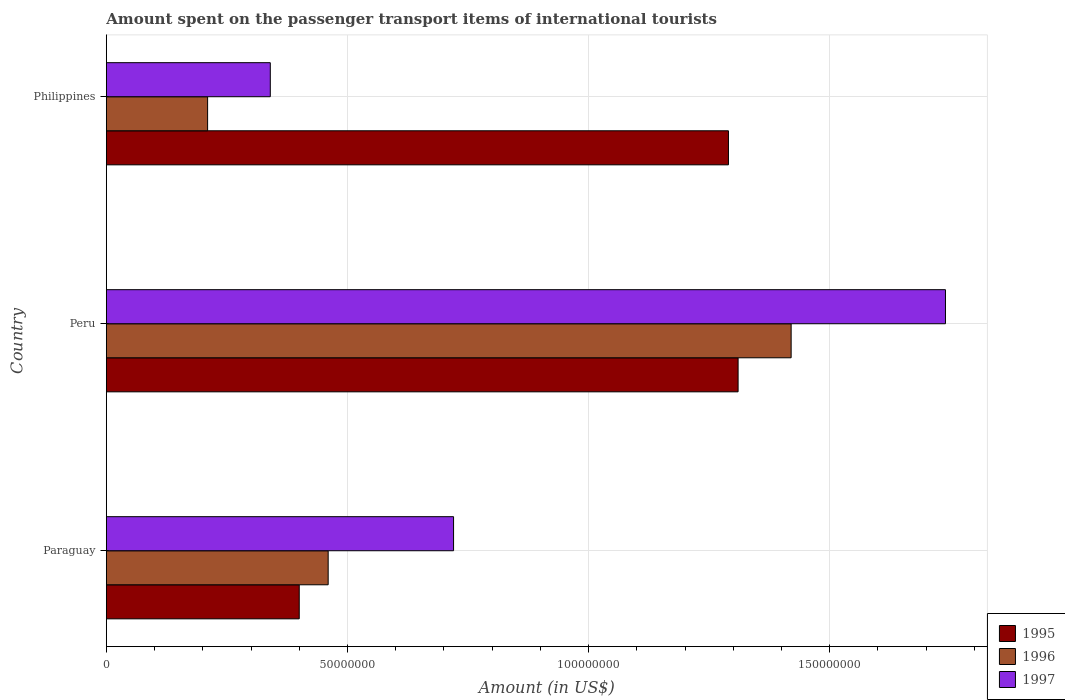How many different coloured bars are there?
Provide a short and direct response. 3. How many groups of bars are there?
Ensure brevity in your answer.  3. How many bars are there on the 3rd tick from the bottom?
Keep it short and to the point. 3. What is the label of the 3rd group of bars from the top?
Offer a terse response. Paraguay. In how many cases, is the number of bars for a given country not equal to the number of legend labels?
Keep it short and to the point. 0. What is the amount spent on the passenger transport items of international tourists in 1997 in Paraguay?
Keep it short and to the point. 7.20e+07. Across all countries, what is the maximum amount spent on the passenger transport items of international tourists in 1995?
Make the answer very short. 1.31e+08. Across all countries, what is the minimum amount spent on the passenger transport items of international tourists in 1997?
Keep it short and to the point. 3.40e+07. In which country was the amount spent on the passenger transport items of international tourists in 1996 minimum?
Your answer should be very brief. Philippines. What is the total amount spent on the passenger transport items of international tourists in 1996 in the graph?
Ensure brevity in your answer.  2.09e+08. What is the difference between the amount spent on the passenger transport items of international tourists in 1995 in Paraguay and that in Philippines?
Your answer should be very brief. -8.90e+07. What is the difference between the amount spent on the passenger transport items of international tourists in 1995 in Peru and the amount spent on the passenger transport items of international tourists in 1996 in Philippines?
Keep it short and to the point. 1.10e+08. What is the average amount spent on the passenger transport items of international tourists in 1997 per country?
Your answer should be compact. 9.33e+07. What is the difference between the amount spent on the passenger transport items of international tourists in 1995 and amount spent on the passenger transport items of international tourists in 1996 in Paraguay?
Your response must be concise. -6.00e+06. What is the ratio of the amount spent on the passenger transport items of international tourists in 1996 in Paraguay to that in Peru?
Provide a short and direct response. 0.32. Is the amount spent on the passenger transport items of international tourists in 1995 in Paraguay less than that in Peru?
Offer a very short reply. Yes. What is the difference between the highest and the second highest amount spent on the passenger transport items of international tourists in 1997?
Offer a very short reply. 1.02e+08. What is the difference between the highest and the lowest amount spent on the passenger transport items of international tourists in 1995?
Your response must be concise. 9.10e+07. In how many countries, is the amount spent on the passenger transport items of international tourists in 1996 greater than the average amount spent on the passenger transport items of international tourists in 1996 taken over all countries?
Keep it short and to the point. 1. Are all the bars in the graph horizontal?
Provide a short and direct response. Yes. How many countries are there in the graph?
Provide a succinct answer. 3. Does the graph contain grids?
Ensure brevity in your answer.  Yes. How many legend labels are there?
Provide a short and direct response. 3. How are the legend labels stacked?
Provide a succinct answer. Vertical. What is the title of the graph?
Keep it short and to the point. Amount spent on the passenger transport items of international tourists. What is the label or title of the Y-axis?
Your response must be concise. Country. What is the Amount (in US$) of 1995 in Paraguay?
Give a very brief answer. 4.00e+07. What is the Amount (in US$) of 1996 in Paraguay?
Give a very brief answer. 4.60e+07. What is the Amount (in US$) in 1997 in Paraguay?
Offer a terse response. 7.20e+07. What is the Amount (in US$) in 1995 in Peru?
Your answer should be compact. 1.31e+08. What is the Amount (in US$) of 1996 in Peru?
Your answer should be very brief. 1.42e+08. What is the Amount (in US$) of 1997 in Peru?
Your answer should be very brief. 1.74e+08. What is the Amount (in US$) in 1995 in Philippines?
Offer a very short reply. 1.29e+08. What is the Amount (in US$) in 1996 in Philippines?
Your answer should be compact. 2.10e+07. What is the Amount (in US$) of 1997 in Philippines?
Your answer should be compact. 3.40e+07. Across all countries, what is the maximum Amount (in US$) in 1995?
Offer a terse response. 1.31e+08. Across all countries, what is the maximum Amount (in US$) of 1996?
Ensure brevity in your answer.  1.42e+08. Across all countries, what is the maximum Amount (in US$) in 1997?
Keep it short and to the point. 1.74e+08. Across all countries, what is the minimum Amount (in US$) of 1995?
Your response must be concise. 4.00e+07. Across all countries, what is the minimum Amount (in US$) of 1996?
Your response must be concise. 2.10e+07. Across all countries, what is the minimum Amount (in US$) of 1997?
Your response must be concise. 3.40e+07. What is the total Amount (in US$) in 1995 in the graph?
Your answer should be compact. 3.00e+08. What is the total Amount (in US$) in 1996 in the graph?
Provide a succinct answer. 2.09e+08. What is the total Amount (in US$) of 1997 in the graph?
Ensure brevity in your answer.  2.80e+08. What is the difference between the Amount (in US$) in 1995 in Paraguay and that in Peru?
Offer a terse response. -9.10e+07. What is the difference between the Amount (in US$) of 1996 in Paraguay and that in Peru?
Ensure brevity in your answer.  -9.60e+07. What is the difference between the Amount (in US$) in 1997 in Paraguay and that in Peru?
Offer a terse response. -1.02e+08. What is the difference between the Amount (in US$) of 1995 in Paraguay and that in Philippines?
Your answer should be compact. -8.90e+07. What is the difference between the Amount (in US$) in 1996 in Paraguay and that in Philippines?
Provide a succinct answer. 2.50e+07. What is the difference between the Amount (in US$) of 1997 in Paraguay and that in Philippines?
Your answer should be compact. 3.80e+07. What is the difference between the Amount (in US$) in 1996 in Peru and that in Philippines?
Give a very brief answer. 1.21e+08. What is the difference between the Amount (in US$) in 1997 in Peru and that in Philippines?
Your response must be concise. 1.40e+08. What is the difference between the Amount (in US$) of 1995 in Paraguay and the Amount (in US$) of 1996 in Peru?
Your response must be concise. -1.02e+08. What is the difference between the Amount (in US$) in 1995 in Paraguay and the Amount (in US$) in 1997 in Peru?
Your answer should be compact. -1.34e+08. What is the difference between the Amount (in US$) of 1996 in Paraguay and the Amount (in US$) of 1997 in Peru?
Keep it short and to the point. -1.28e+08. What is the difference between the Amount (in US$) of 1995 in Paraguay and the Amount (in US$) of 1996 in Philippines?
Your answer should be very brief. 1.90e+07. What is the difference between the Amount (in US$) in 1995 in Paraguay and the Amount (in US$) in 1997 in Philippines?
Provide a succinct answer. 6.00e+06. What is the difference between the Amount (in US$) in 1996 in Paraguay and the Amount (in US$) in 1997 in Philippines?
Provide a short and direct response. 1.20e+07. What is the difference between the Amount (in US$) of 1995 in Peru and the Amount (in US$) of 1996 in Philippines?
Provide a short and direct response. 1.10e+08. What is the difference between the Amount (in US$) of 1995 in Peru and the Amount (in US$) of 1997 in Philippines?
Offer a very short reply. 9.70e+07. What is the difference between the Amount (in US$) of 1996 in Peru and the Amount (in US$) of 1997 in Philippines?
Ensure brevity in your answer.  1.08e+08. What is the average Amount (in US$) of 1995 per country?
Make the answer very short. 1.00e+08. What is the average Amount (in US$) of 1996 per country?
Make the answer very short. 6.97e+07. What is the average Amount (in US$) of 1997 per country?
Keep it short and to the point. 9.33e+07. What is the difference between the Amount (in US$) in 1995 and Amount (in US$) in 1996 in Paraguay?
Ensure brevity in your answer.  -6.00e+06. What is the difference between the Amount (in US$) of 1995 and Amount (in US$) of 1997 in Paraguay?
Offer a very short reply. -3.20e+07. What is the difference between the Amount (in US$) of 1996 and Amount (in US$) of 1997 in Paraguay?
Your answer should be very brief. -2.60e+07. What is the difference between the Amount (in US$) of 1995 and Amount (in US$) of 1996 in Peru?
Give a very brief answer. -1.10e+07. What is the difference between the Amount (in US$) in 1995 and Amount (in US$) in 1997 in Peru?
Keep it short and to the point. -4.30e+07. What is the difference between the Amount (in US$) in 1996 and Amount (in US$) in 1997 in Peru?
Provide a short and direct response. -3.20e+07. What is the difference between the Amount (in US$) of 1995 and Amount (in US$) of 1996 in Philippines?
Your answer should be very brief. 1.08e+08. What is the difference between the Amount (in US$) in 1995 and Amount (in US$) in 1997 in Philippines?
Make the answer very short. 9.50e+07. What is the difference between the Amount (in US$) in 1996 and Amount (in US$) in 1997 in Philippines?
Offer a very short reply. -1.30e+07. What is the ratio of the Amount (in US$) of 1995 in Paraguay to that in Peru?
Your answer should be very brief. 0.31. What is the ratio of the Amount (in US$) in 1996 in Paraguay to that in Peru?
Your answer should be compact. 0.32. What is the ratio of the Amount (in US$) of 1997 in Paraguay to that in Peru?
Your answer should be compact. 0.41. What is the ratio of the Amount (in US$) in 1995 in Paraguay to that in Philippines?
Give a very brief answer. 0.31. What is the ratio of the Amount (in US$) in 1996 in Paraguay to that in Philippines?
Keep it short and to the point. 2.19. What is the ratio of the Amount (in US$) of 1997 in Paraguay to that in Philippines?
Your answer should be compact. 2.12. What is the ratio of the Amount (in US$) of 1995 in Peru to that in Philippines?
Provide a succinct answer. 1.02. What is the ratio of the Amount (in US$) of 1996 in Peru to that in Philippines?
Offer a very short reply. 6.76. What is the ratio of the Amount (in US$) in 1997 in Peru to that in Philippines?
Offer a terse response. 5.12. What is the difference between the highest and the second highest Amount (in US$) of 1996?
Provide a short and direct response. 9.60e+07. What is the difference between the highest and the second highest Amount (in US$) of 1997?
Your answer should be compact. 1.02e+08. What is the difference between the highest and the lowest Amount (in US$) of 1995?
Ensure brevity in your answer.  9.10e+07. What is the difference between the highest and the lowest Amount (in US$) of 1996?
Offer a terse response. 1.21e+08. What is the difference between the highest and the lowest Amount (in US$) in 1997?
Offer a terse response. 1.40e+08. 